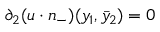Convert formula to latex. <formula><loc_0><loc_0><loc_500><loc_500>\partial _ { 2 } ( u \cdot n _ { - } ) ( y _ { 1 } , \bar { y } _ { 2 } ) = 0</formula> 